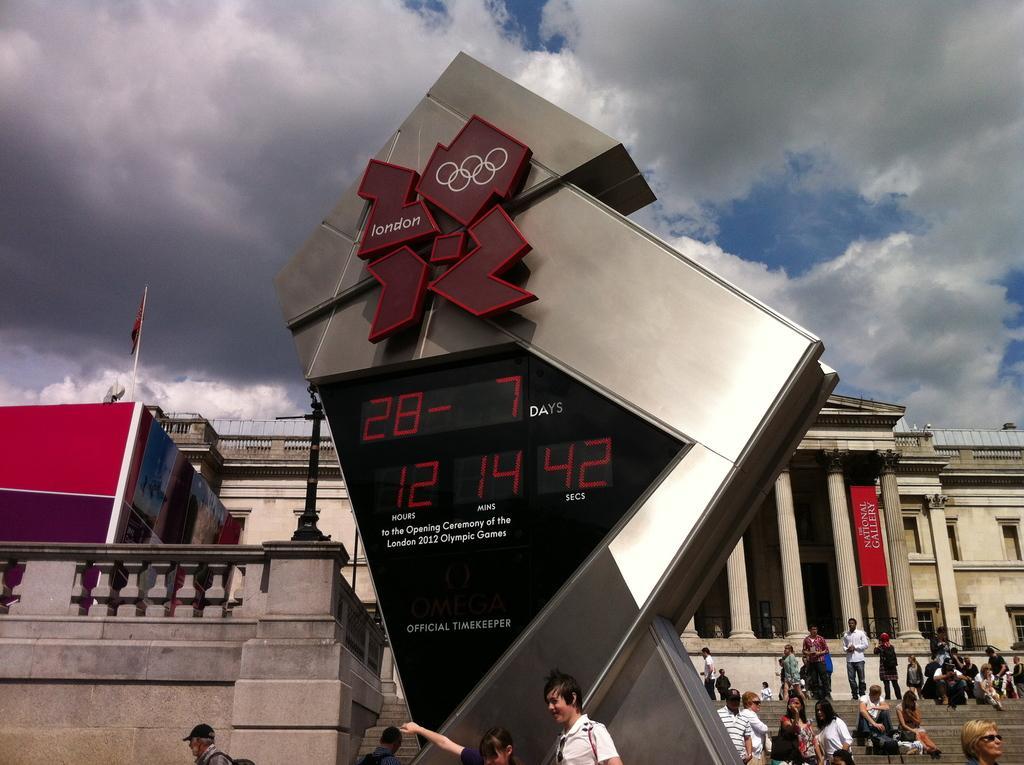Please provide a concise description of this image. In this picture I see a thing in front on which there is a screen and on the screen I see numbers and something is written near to it and I see number of people and in the middle of this image I see the buildings and in the background I see the cloudy sky. 